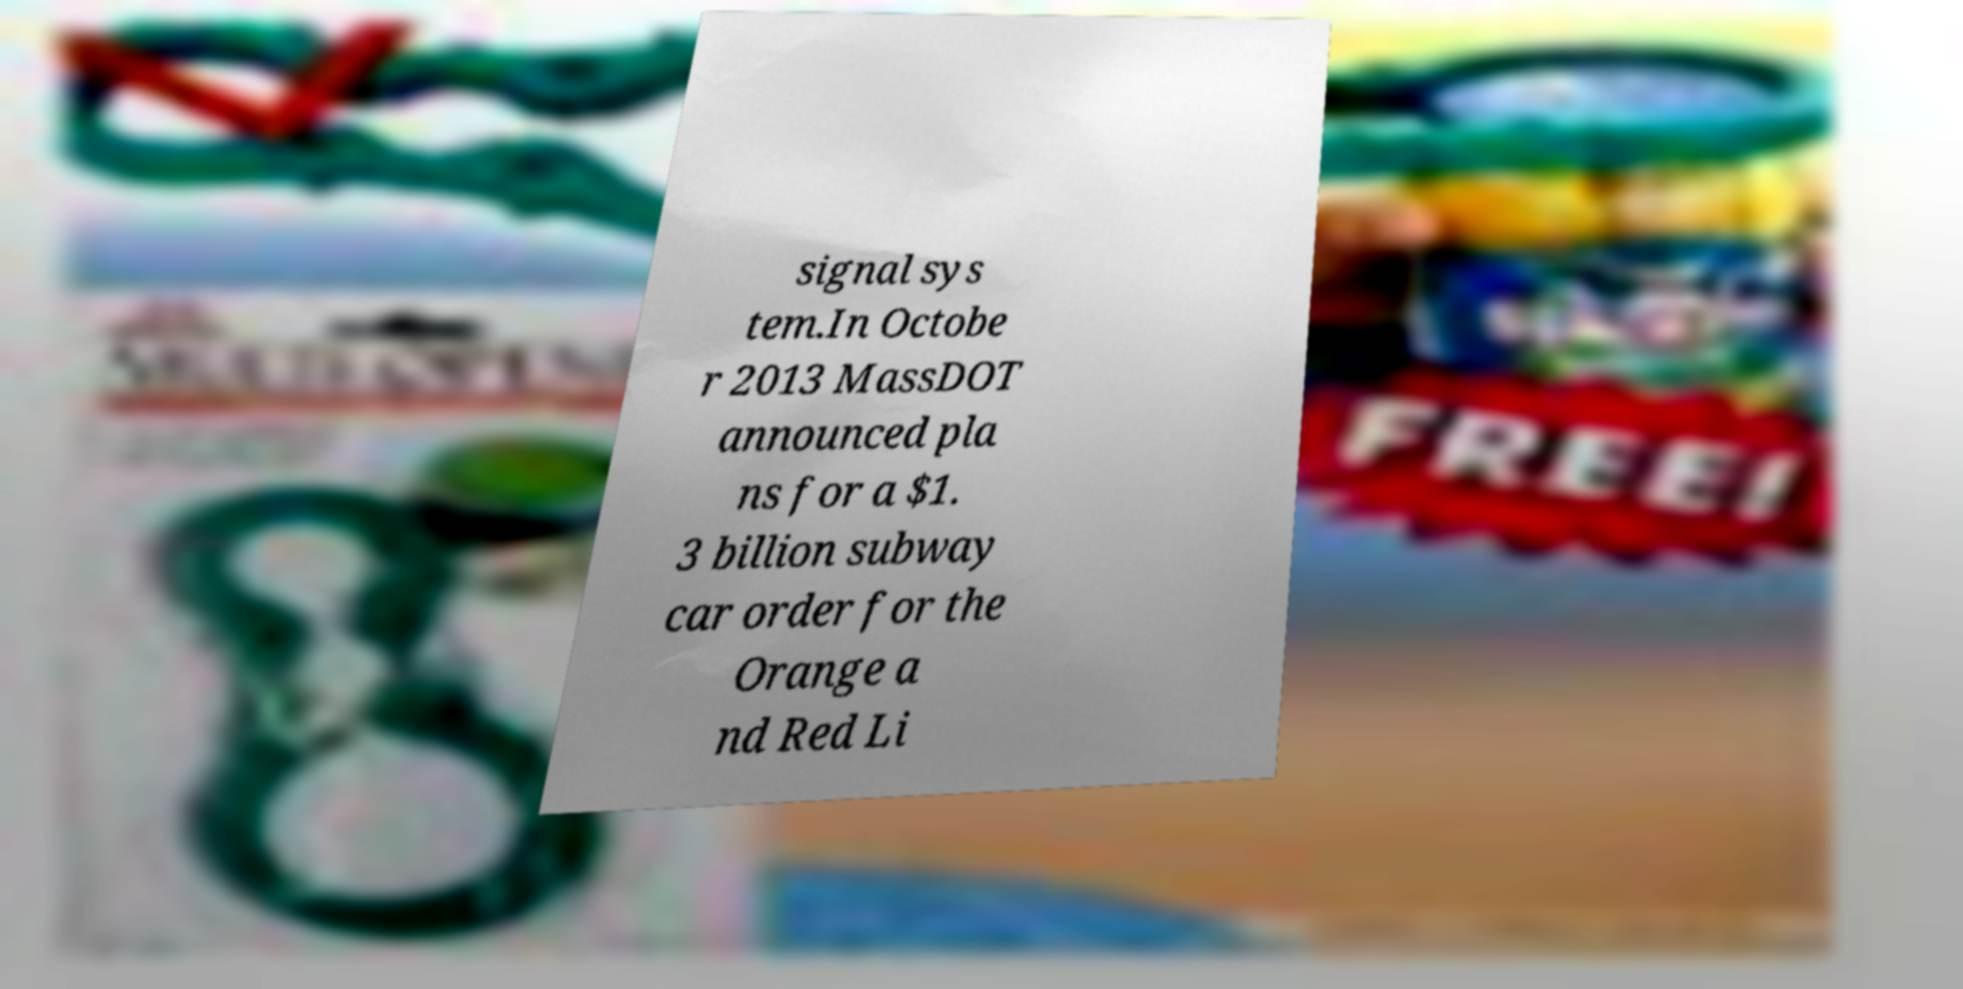There's text embedded in this image that I need extracted. Can you transcribe it verbatim? signal sys tem.In Octobe r 2013 MassDOT announced pla ns for a $1. 3 billion subway car order for the Orange a nd Red Li 